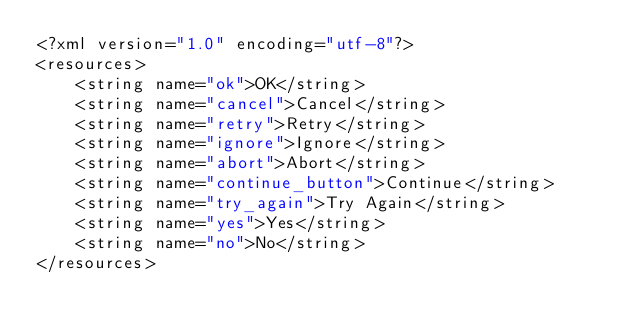Convert code to text. <code><loc_0><loc_0><loc_500><loc_500><_XML_><?xml version="1.0" encoding="utf-8"?>
<resources>
    <string name="ok">OK</string>
    <string name="cancel">Cancel</string>
    <string name="retry">Retry</string>
    <string name="ignore">Ignore</string>
    <string name="abort">Abort</string>
    <string name="continue_button">Continue</string>
    <string name="try_again">Try Again</string>
    <string name="yes">Yes</string>
    <string name="no">No</string>
</resources></code> 